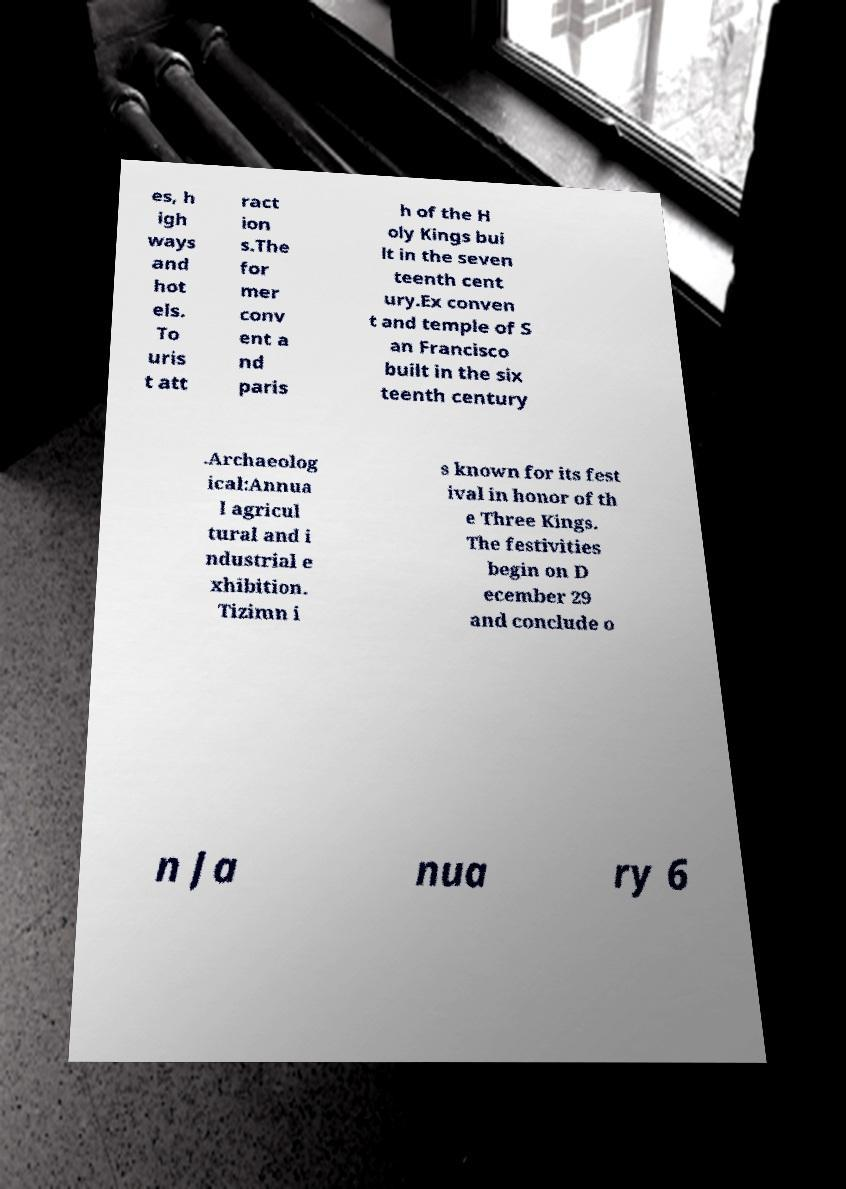For documentation purposes, I need the text within this image transcribed. Could you provide that? es, h igh ways and hot els. To uris t att ract ion s.The for mer conv ent a nd paris h of the H oly Kings bui lt in the seven teenth cent ury.Ex conven t and temple of S an Francisco built in the six teenth century .Archaeolog ical:Annua l agricul tural and i ndustrial e xhibition. Tizimn i s known for its fest ival in honor of th e Three Kings. The festivities begin on D ecember 29 and conclude o n Ja nua ry 6 